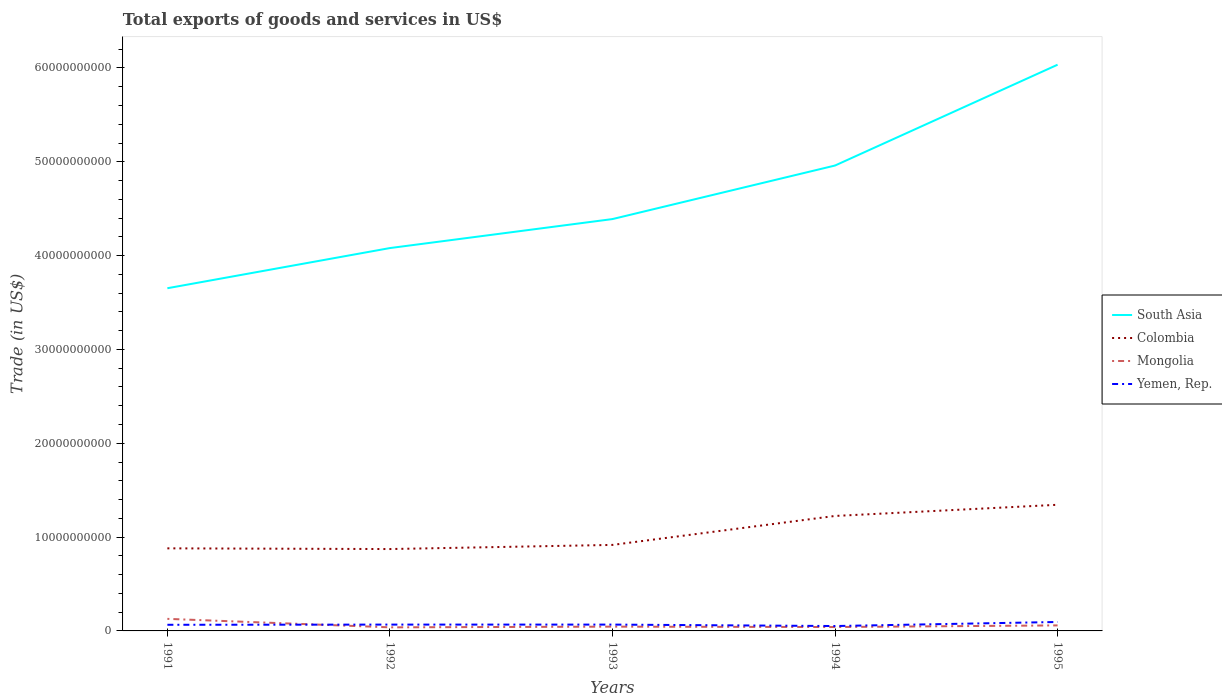Is the number of lines equal to the number of legend labels?
Your response must be concise. Yes. Across all years, what is the maximum total exports of goods and services in Yemen, Rep.?
Your answer should be very brief. 5.21e+08. In which year was the total exports of goods and services in Mongolia maximum?
Offer a terse response. 1992. What is the total total exports of goods and services in Yemen, Rep. in the graph?
Keep it short and to the point. -5.11e+05. What is the difference between the highest and the second highest total exports of goods and services in Yemen, Rep.?
Offer a terse response. 4.32e+08. Is the total exports of goods and services in Yemen, Rep. strictly greater than the total exports of goods and services in Mongolia over the years?
Provide a succinct answer. No. How many lines are there?
Ensure brevity in your answer.  4. How many years are there in the graph?
Offer a terse response. 5. What is the difference between two consecutive major ticks on the Y-axis?
Make the answer very short. 1.00e+1. Are the values on the major ticks of Y-axis written in scientific E-notation?
Keep it short and to the point. No. Does the graph contain any zero values?
Keep it short and to the point. No. Does the graph contain grids?
Offer a terse response. No. Where does the legend appear in the graph?
Keep it short and to the point. Center right. How many legend labels are there?
Provide a succinct answer. 4. How are the legend labels stacked?
Provide a short and direct response. Vertical. What is the title of the graph?
Provide a short and direct response. Total exports of goods and services in US$. What is the label or title of the X-axis?
Your answer should be compact. Years. What is the label or title of the Y-axis?
Give a very brief answer. Trade (in US$). What is the Trade (in US$) in South Asia in 1991?
Provide a short and direct response. 3.65e+1. What is the Trade (in US$) of Colombia in 1991?
Make the answer very short. 8.80e+09. What is the Trade (in US$) in Mongolia in 1991?
Give a very brief answer. 1.29e+09. What is the Trade (in US$) in Yemen, Rep. in 1991?
Your answer should be compact. 6.54e+08. What is the Trade (in US$) of South Asia in 1992?
Offer a very short reply. 4.08e+1. What is the Trade (in US$) of Colombia in 1992?
Give a very brief answer. 8.73e+09. What is the Trade (in US$) of Mongolia in 1992?
Ensure brevity in your answer.  3.81e+08. What is the Trade (in US$) of Yemen, Rep. in 1992?
Make the answer very short. 6.75e+08. What is the Trade (in US$) in South Asia in 1993?
Provide a succinct answer. 4.39e+1. What is the Trade (in US$) of Colombia in 1993?
Keep it short and to the point. 9.17e+09. What is the Trade (in US$) in Mongolia in 1993?
Make the answer very short. 4.56e+08. What is the Trade (in US$) in Yemen, Rep. in 1993?
Your answer should be very brief. 6.75e+08. What is the Trade (in US$) of South Asia in 1994?
Your response must be concise. 4.96e+1. What is the Trade (in US$) of Colombia in 1994?
Give a very brief answer. 1.23e+1. What is the Trade (in US$) in Mongolia in 1994?
Provide a short and direct response. 4.13e+08. What is the Trade (in US$) in Yemen, Rep. in 1994?
Give a very brief answer. 5.21e+08. What is the Trade (in US$) in South Asia in 1995?
Your answer should be very brief. 6.03e+1. What is the Trade (in US$) in Colombia in 1995?
Your answer should be very brief. 1.34e+1. What is the Trade (in US$) of Mongolia in 1995?
Your response must be concise. 5.89e+08. What is the Trade (in US$) of Yemen, Rep. in 1995?
Make the answer very short. 9.53e+08. Across all years, what is the maximum Trade (in US$) in South Asia?
Provide a succinct answer. 6.03e+1. Across all years, what is the maximum Trade (in US$) in Colombia?
Give a very brief answer. 1.34e+1. Across all years, what is the maximum Trade (in US$) in Mongolia?
Offer a very short reply. 1.29e+09. Across all years, what is the maximum Trade (in US$) of Yemen, Rep.?
Give a very brief answer. 9.53e+08. Across all years, what is the minimum Trade (in US$) of South Asia?
Offer a very short reply. 3.65e+1. Across all years, what is the minimum Trade (in US$) of Colombia?
Provide a short and direct response. 8.73e+09. Across all years, what is the minimum Trade (in US$) in Mongolia?
Keep it short and to the point. 3.81e+08. Across all years, what is the minimum Trade (in US$) in Yemen, Rep.?
Your answer should be very brief. 5.21e+08. What is the total Trade (in US$) of South Asia in the graph?
Your answer should be very brief. 2.31e+11. What is the total Trade (in US$) in Colombia in the graph?
Your answer should be very brief. 5.24e+1. What is the total Trade (in US$) of Mongolia in the graph?
Provide a succinct answer. 3.13e+09. What is the total Trade (in US$) in Yemen, Rep. in the graph?
Provide a short and direct response. 3.48e+09. What is the difference between the Trade (in US$) of South Asia in 1991 and that in 1992?
Offer a terse response. -4.28e+09. What is the difference between the Trade (in US$) in Colombia in 1991 and that in 1992?
Your response must be concise. 7.52e+07. What is the difference between the Trade (in US$) of Mongolia in 1991 and that in 1992?
Provide a succinct answer. 9.05e+08. What is the difference between the Trade (in US$) of Yemen, Rep. in 1991 and that in 1992?
Make the answer very short. -2.09e+07. What is the difference between the Trade (in US$) in South Asia in 1991 and that in 1993?
Your answer should be very brief. -7.37e+09. What is the difference between the Trade (in US$) in Colombia in 1991 and that in 1993?
Your answer should be compact. -3.66e+08. What is the difference between the Trade (in US$) of Mongolia in 1991 and that in 1993?
Keep it short and to the point. 8.30e+08. What is the difference between the Trade (in US$) in Yemen, Rep. in 1991 and that in 1993?
Offer a very short reply. -2.14e+07. What is the difference between the Trade (in US$) of South Asia in 1991 and that in 1994?
Provide a short and direct response. -1.31e+1. What is the difference between the Trade (in US$) of Colombia in 1991 and that in 1994?
Provide a succinct answer. -3.45e+09. What is the difference between the Trade (in US$) of Mongolia in 1991 and that in 1994?
Your answer should be compact. 8.73e+08. What is the difference between the Trade (in US$) of Yemen, Rep. in 1991 and that in 1994?
Offer a terse response. 1.32e+08. What is the difference between the Trade (in US$) of South Asia in 1991 and that in 1995?
Offer a terse response. -2.38e+1. What is the difference between the Trade (in US$) in Colombia in 1991 and that in 1995?
Your answer should be very brief. -4.64e+09. What is the difference between the Trade (in US$) of Mongolia in 1991 and that in 1995?
Ensure brevity in your answer.  6.98e+08. What is the difference between the Trade (in US$) in Yemen, Rep. in 1991 and that in 1995?
Make the answer very short. -2.99e+08. What is the difference between the Trade (in US$) in South Asia in 1992 and that in 1993?
Ensure brevity in your answer.  -3.09e+09. What is the difference between the Trade (in US$) of Colombia in 1992 and that in 1993?
Give a very brief answer. -4.41e+08. What is the difference between the Trade (in US$) in Mongolia in 1992 and that in 1993?
Keep it short and to the point. -7.47e+07. What is the difference between the Trade (in US$) of Yemen, Rep. in 1992 and that in 1993?
Provide a succinct answer. -5.11e+05. What is the difference between the Trade (in US$) in South Asia in 1992 and that in 1994?
Your answer should be compact. -8.80e+09. What is the difference between the Trade (in US$) in Colombia in 1992 and that in 1994?
Offer a terse response. -3.53e+09. What is the difference between the Trade (in US$) of Mongolia in 1992 and that in 1994?
Provide a succinct answer. -3.20e+07. What is the difference between the Trade (in US$) of Yemen, Rep. in 1992 and that in 1994?
Provide a succinct answer. 1.53e+08. What is the difference between the Trade (in US$) in South Asia in 1992 and that in 1995?
Give a very brief answer. -1.95e+1. What is the difference between the Trade (in US$) in Colombia in 1992 and that in 1995?
Your answer should be very brief. -4.72e+09. What is the difference between the Trade (in US$) in Mongolia in 1992 and that in 1995?
Your answer should be compact. -2.08e+08. What is the difference between the Trade (in US$) in Yemen, Rep. in 1992 and that in 1995?
Keep it short and to the point. -2.78e+08. What is the difference between the Trade (in US$) of South Asia in 1993 and that in 1994?
Your response must be concise. -5.71e+09. What is the difference between the Trade (in US$) in Colombia in 1993 and that in 1994?
Your answer should be very brief. -3.09e+09. What is the difference between the Trade (in US$) in Mongolia in 1993 and that in 1994?
Make the answer very short. 4.27e+07. What is the difference between the Trade (in US$) in Yemen, Rep. in 1993 and that in 1994?
Offer a very short reply. 1.54e+08. What is the difference between the Trade (in US$) of South Asia in 1993 and that in 1995?
Offer a very short reply. -1.65e+1. What is the difference between the Trade (in US$) in Colombia in 1993 and that in 1995?
Your response must be concise. -4.28e+09. What is the difference between the Trade (in US$) of Mongolia in 1993 and that in 1995?
Offer a very short reply. -1.33e+08. What is the difference between the Trade (in US$) in Yemen, Rep. in 1993 and that in 1995?
Make the answer very short. -2.78e+08. What is the difference between the Trade (in US$) in South Asia in 1994 and that in 1995?
Ensure brevity in your answer.  -1.07e+1. What is the difference between the Trade (in US$) in Colombia in 1994 and that in 1995?
Offer a terse response. -1.19e+09. What is the difference between the Trade (in US$) in Mongolia in 1994 and that in 1995?
Your answer should be compact. -1.76e+08. What is the difference between the Trade (in US$) in Yemen, Rep. in 1994 and that in 1995?
Keep it short and to the point. -4.32e+08. What is the difference between the Trade (in US$) of South Asia in 1991 and the Trade (in US$) of Colombia in 1992?
Your answer should be compact. 2.78e+1. What is the difference between the Trade (in US$) in South Asia in 1991 and the Trade (in US$) in Mongolia in 1992?
Provide a short and direct response. 3.61e+1. What is the difference between the Trade (in US$) of South Asia in 1991 and the Trade (in US$) of Yemen, Rep. in 1992?
Your answer should be very brief. 3.58e+1. What is the difference between the Trade (in US$) in Colombia in 1991 and the Trade (in US$) in Mongolia in 1992?
Give a very brief answer. 8.42e+09. What is the difference between the Trade (in US$) in Colombia in 1991 and the Trade (in US$) in Yemen, Rep. in 1992?
Give a very brief answer. 8.13e+09. What is the difference between the Trade (in US$) of Mongolia in 1991 and the Trade (in US$) of Yemen, Rep. in 1992?
Make the answer very short. 6.12e+08. What is the difference between the Trade (in US$) in South Asia in 1991 and the Trade (in US$) in Colombia in 1993?
Provide a short and direct response. 2.74e+1. What is the difference between the Trade (in US$) in South Asia in 1991 and the Trade (in US$) in Mongolia in 1993?
Your answer should be compact. 3.61e+1. What is the difference between the Trade (in US$) of South Asia in 1991 and the Trade (in US$) of Yemen, Rep. in 1993?
Offer a terse response. 3.58e+1. What is the difference between the Trade (in US$) of Colombia in 1991 and the Trade (in US$) of Mongolia in 1993?
Make the answer very short. 8.35e+09. What is the difference between the Trade (in US$) of Colombia in 1991 and the Trade (in US$) of Yemen, Rep. in 1993?
Make the answer very short. 8.13e+09. What is the difference between the Trade (in US$) of Mongolia in 1991 and the Trade (in US$) of Yemen, Rep. in 1993?
Your answer should be very brief. 6.11e+08. What is the difference between the Trade (in US$) of South Asia in 1991 and the Trade (in US$) of Colombia in 1994?
Provide a succinct answer. 2.43e+1. What is the difference between the Trade (in US$) of South Asia in 1991 and the Trade (in US$) of Mongolia in 1994?
Your answer should be very brief. 3.61e+1. What is the difference between the Trade (in US$) in South Asia in 1991 and the Trade (in US$) in Yemen, Rep. in 1994?
Offer a terse response. 3.60e+1. What is the difference between the Trade (in US$) in Colombia in 1991 and the Trade (in US$) in Mongolia in 1994?
Ensure brevity in your answer.  8.39e+09. What is the difference between the Trade (in US$) of Colombia in 1991 and the Trade (in US$) of Yemen, Rep. in 1994?
Offer a terse response. 8.28e+09. What is the difference between the Trade (in US$) in Mongolia in 1991 and the Trade (in US$) in Yemen, Rep. in 1994?
Provide a succinct answer. 7.65e+08. What is the difference between the Trade (in US$) in South Asia in 1991 and the Trade (in US$) in Colombia in 1995?
Provide a short and direct response. 2.31e+1. What is the difference between the Trade (in US$) of South Asia in 1991 and the Trade (in US$) of Mongolia in 1995?
Give a very brief answer. 3.59e+1. What is the difference between the Trade (in US$) in South Asia in 1991 and the Trade (in US$) in Yemen, Rep. in 1995?
Offer a terse response. 3.56e+1. What is the difference between the Trade (in US$) of Colombia in 1991 and the Trade (in US$) of Mongolia in 1995?
Your answer should be very brief. 8.21e+09. What is the difference between the Trade (in US$) of Colombia in 1991 and the Trade (in US$) of Yemen, Rep. in 1995?
Ensure brevity in your answer.  7.85e+09. What is the difference between the Trade (in US$) of Mongolia in 1991 and the Trade (in US$) of Yemen, Rep. in 1995?
Offer a terse response. 3.33e+08. What is the difference between the Trade (in US$) of South Asia in 1992 and the Trade (in US$) of Colombia in 1993?
Ensure brevity in your answer.  3.16e+1. What is the difference between the Trade (in US$) of South Asia in 1992 and the Trade (in US$) of Mongolia in 1993?
Your answer should be compact. 4.04e+1. What is the difference between the Trade (in US$) in South Asia in 1992 and the Trade (in US$) in Yemen, Rep. in 1993?
Make the answer very short. 4.01e+1. What is the difference between the Trade (in US$) of Colombia in 1992 and the Trade (in US$) of Mongolia in 1993?
Keep it short and to the point. 8.27e+09. What is the difference between the Trade (in US$) of Colombia in 1992 and the Trade (in US$) of Yemen, Rep. in 1993?
Your response must be concise. 8.05e+09. What is the difference between the Trade (in US$) in Mongolia in 1992 and the Trade (in US$) in Yemen, Rep. in 1993?
Make the answer very short. -2.94e+08. What is the difference between the Trade (in US$) in South Asia in 1992 and the Trade (in US$) in Colombia in 1994?
Your answer should be very brief. 2.86e+1. What is the difference between the Trade (in US$) in South Asia in 1992 and the Trade (in US$) in Mongolia in 1994?
Provide a short and direct response. 4.04e+1. What is the difference between the Trade (in US$) of South Asia in 1992 and the Trade (in US$) of Yemen, Rep. in 1994?
Make the answer very short. 4.03e+1. What is the difference between the Trade (in US$) in Colombia in 1992 and the Trade (in US$) in Mongolia in 1994?
Offer a terse response. 8.31e+09. What is the difference between the Trade (in US$) in Colombia in 1992 and the Trade (in US$) in Yemen, Rep. in 1994?
Give a very brief answer. 8.21e+09. What is the difference between the Trade (in US$) of Mongolia in 1992 and the Trade (in US$) of Yemen, Rep. in 1994?
Ensure brevity in your answer.  -1.40e+08. What is the difference between the Trade (in US$) of South Asia in 1992 and the Trade (in US$) of Colombia in 1995?
Make the answer very short. 2.74e+1. What is the difference between the Trade (in US$) in South Asia in 1992 and the Trade (in US$) in Mongolia in 1995?
Ensure brevity in your answer.  4.02e+1. What is the difference between the Trade (in US$) in South Asia in 1992 and the Trade (in US$) in Yemen, Rep. in 1995?
Give a very brief answer. 3.99e+1. What is the difference between the Trade (in US$) in Colombia in 1992 and the Trade (in US$) in Mongolia in 1995?
Make the answer very short. 8.14e+09. What is the difference between the Trade (in US$) in Colombia in 1992 and the Trade (in US$) in Yemen, Rep. in 1995?
Give a very brief answer. 7.77e+09. What is the difference between the Trade (in US$) in Mongolia in 1992 and the Trade (in US$) in Yemen, Rep. in 1995?
Provide a succinct answer. -5.72e+08. What is the difference between the Trade (in US$) of South Asia in 1993 and the Trade (in US$) of Colombia in 1994?
Keep it short and to the point. 3.16e+1. What is the difference between the Trade (in US$) in South Asia in 1993 and the Trade (in US$) in Mongolia in 1994?
Your answer should be very brief. 4.35e+1. What is the difference between the Trade (in US$) in South Asia in 1993 and the Trade (in US$) in Yemen, Rep. in 1994?
Offer a very short reply. 4.34e+1. What is the difference between the Trade (in US$) in Colombia in 1993 and the Trade (in US$) in Mongolia in 1994?
Your answer should be compact. 8.75e+09. What is the difference between the Trade (in US$) in Colombia in 1993 and the Trade (in US$) in Yemen, Rep. in 1994?
Your answer should be very brief. 8.65e+09. What is the difference between the Trade (in US$) in Mongolia in 1993 and the Trade (in US$) in Yemen, Rep. in 1994?
Your answer should be very brief. -6.53e+07. What is the difference between the Trade (in US$) of South Asia in 1993 and the Trade (in US$) of Colombia in 1995?
Your answer should be compact. 3.05e+1. What is the difference between the Trade (in US$) of South Asia in 1993 and the Trade (in US$) of Mongolia in 1995?
Your response must be concise. 4.33e+1. What is the difference between the Trade (in US$) in South Asia in 1993 and the Trade (in US$) in Yemen, Rep. in 1995?
Your answer should be compact. 4.29e+1. What is the difference between the Trade (in US$) in Colombia in 1993 and the Trade (in US$) in Mongolia in 1995?
Keep it short and to the point. 8.58e+09. What is the difference between the Trade (in US$) of Colombia in 1993 and the Trade (in US$) of Yemen, Rep. in 1995?
Keep it short and to the point. 8.21e+09. What is the difference between the Trade (in US$) in Mongolia in 1993 and the Trade (in US$) in Yemen, Rep. in 1995?
Keep it short and to the point. -4.97e+08. What is the difference between the Trade (in US$) in South Asia in 1994 and the Trade (in US$) in Colombia in 1995?
Your answer should be very brief. 3.62e+1. What is the difference between the Trade (in US$) of South Asia in 1994 and the Trade (in US$) of Mongolia in 1995?
Make the answer very short. 4.90e+1. What is the difference between the Trade (in US$) of South Asia in 1994 and the Trade (in US$) of Yemen, Rep. in 1995?
Your response must be concise. 4.87e+1. What is the difference between the Trade (in US$) in Colombia in 1994 and the Trade (in US$) in Mongolia in 1995?
Offer a very short reply. 1.17e+1. What is the difference between the Trade (in US$) of Colombia in 1994 and the Trade (in US$) of Yemen, Rep. in 1995?
Make the answer very short. 1.13e+1. What is the difference between the Trade (in US$) of Mongolia in 1994 and the Trade (in US$) of Yemen, Rep. in 1995?
Make the answer very short. -5.40e+08. What is the average Trade (in US$) in South Asia per year?
Provide a succinct answer. 4.62e+1. What is the average Trade (in US$) in Colombia per year?
Offer a very short reply. 1.05e+1. What is the average Trade (in US$) of Mongolia per year?
Offer a terse response. 6.25e+08. What is the average Trade (in US$) of Yemen, Rep. per year?
Keep it short and to the point. 6.96e+08. In the year 1991, what is the difference between the Trade (in US$) of South Asia and Trade (in US$) of Colombia?
Your response must be concise. 2.77e+1. In the year 1991, what is the difference between the Trade (in US$) of South Asia and Trade (in US$) of Mongolia?
Provide a succinct answer. 3.52e+1. In the year 1991, what is the difference between the Trade (in US$) of South Asia and Trade (in US$) of Yemen, Rep.?
Give a very brief answer. 3.59e+1. In the year 1991, what is the difference between the Trade (in US$) in Colombia and Trade (in US$) in Mongolia?
Ensure brevity in your answer.  7.52e+09. In the year 1991, what is the difference between the Trade (in US$) in Colombia and Trade (in US$) in Yemen, Rep.?
Offer a terse response. 8.15e+09. In the year 1991, what is the difference between the Trade (in US$) in Mongolia and Trade (in US$) in Yemen, Rep.?
Provide a short and direct response. 6.33e+08. In the year 1992, what is the difference between the Trade (in US$) of South Asia and Trade (in US$) of Colombia?
Your answer should be very brief. 3.21e+1. In the year 1992, what is the difference between the Trade (in US$) in South Asia and Trade (in US$) in Mongolia?
Offer a very short reply. 4.04e+1. In the year 1992, what is the difference between the Trade (in US$) of South Asia and Trade (in US$) of Yemen, Rep.?
Provide a short and direct response. 4.01e+1. In the year 1992, what is the difference between the Trade (in US$) of Colombia and Trade (in US$) of Mongolia?
Keep it short and to the point. 8.35e+09. In the year 1992, what is the difference between the Trade (in US$) of Colombia and Trade (in US$) of Yemen, Rep.?
Give a very brief answer. 8.05e+09. In the year 1992, what is the difference between the Trade (in US$) in Mongolia and Trade (in US$) in Yemen, Rep.?
Keep it short and to the point. -2.93e+08. In the year 1993, what is the difference between the Trade (in US$) in South Asia and Trade (in US$) in Colombia?
Offer a very short reply. 3.47e+1. In the year 1993, what is the difference between the Trade (in US$) of South Asia and Trade (in US$) of Mongolia?
Your answer should be very brief. 4.34e+1. In the year 1993, what is the difference between the Trade (in US$) in South Asia and Trade (in US$) in Yemen, Rep.?
Offer a very short reply. 4.32e+1. In the year 1993, what is the difference between the Trade (in US$) in Colombia and Trade (in US$) in Mongolia?
Offer a very short reply. 8.71e+09. In the year 1993, what is the difference between the Trade (in US$) in Colombia and Trade (in US$) in Yemen, Rep.?
Give a very brief answer. 8.49e+09. In the year 1993, what is the difference between the Trade (in US$) in Mongolia and Trade (in US$) in Yemen, Rep.?
Your answer should be compact. -2.19e+08. In the year 1994, what is the difference between the Trade (in US$) in South Asia and Trade (in US$) in Colombia?
Provide a succinct answer. 3.73e+1. In the year 1994, what is the difference between the Trade (in US$) in South Asia and Trade (in US$) in Mongolia?
Ensure brevity in your answer.  4.92e+1. In the year 1994, what is the difference between the Trade (in US$) of South Asia and Trade (in US$) of Yemen, Rep.?
Your answer should be very brief. 4.91e+1. In the year 1994, what is the difference between the Trade (in US$) in Colombia and Trade (in US$) in Mongolia?
Make the answer very short. 1.18e+1. In the year 1994, what is the difference between the Trade (in US$) of Colombia and Trade (in US$) of Yemen, Rep.?
Ensure brevity in your answer.  1.17e+1. In the year 1994, what is the difference between the Trade (in US$) of Mongolia and Trade (in US$) of Yemen, Rep.?
Offer a very short reply. -1.08e+08. In the year 1995, what is the difference between the Trade (in US$) in South Asia and Trade (in US$) in Colombia?
Offer a very short reply. 4.69e+1. In the year 1995, what is the difference between the Trade (in US$) in South Asia and Trade (in US$) in Mongolia?
Give a very brief answer. 5.98e+1. In the year 1995, what is the difference between the Trade (in US$) of South Asia and Trade (in US$) of Yemen, Rep.?
Provide a succinct answer. 5.94e+1. In the year 1995, what is the difference between the Trade (in US$) of Colombia and Trade (in US$) of Mongolia?
Your response must be concise. 1.29e+1. In the year 1995, what is the difference between the Trade (in US$) of Colombia and Trade (in US$) of Yemen, Rep.?
Your answer should be very brief. 1.25e+1. In the year 1995, what is the difference between the Trade (in US$) in Mongolia and Trade (in US$) in Yemen, Rep.?
Offer a terse response. -3.64e+08. What is the ratio of the Trade (in US$) of South Asia in 1991 to that in 1992?
Ensure brevity in your answer.  0.9. What is the ratio of the Trade (in US$) of Colombia in 1991 to that in 1992?
Your answer should be compact. 1.01. What is the ratio of the Trade (in US$) of Mongolia in 1991 to that in 1992?
Provide a succinct answer. 3.37. What is the ratio of the Trade (in US$) of South Asia in 1991 to that in 1993?
Offer a terse response. 0.83. What is the ratio of the Trade (in US$) of Colombia in 1991 to that in 1993?
Your response must be concise. 0.96. What is the ratio of the Trade (in US$) in Mongolia in 1991 to that in 1993?
Offer a terse response. 2.82. What is the ratio of the Trade (in US$) of Yemen, Rep. in 1991 to that in 1993?
Make the answer very short. 0.97. What is the ratio of the Trade (in US$) in South Asia in 1991 to that in 1994?
Give a very brief answer. 0.74. What is the ratio of the Trade (in US$) in Colombia in 1991 to that in 1994?
Make the answer very short. 0.72. What is the ratio of the Trade (in US$) of Mongolia in 1991 to that in 1994?
Your answer should be very brief. 3.11. What is the ratio of the Trade (in US$) in Yemen, Rep. in 1991 to that in 1994?
Give a very brief answer. 1.25. What is the ratio of the Trade (in US$) of South Asia in 1991 to that in 1995?
Provide a short and direct response. 0.61. What is the ratio of the Trade (in US$) in Colombia in 1991 to that in 1995?
Your answer should be compact. 0.65. What is the ratio of the Trade (in US$) of Mongolia in 1991 to that in 1995?
Offer a terse response. 2.18. What is the ratio of the Trade (in US$) of Yemen, Rep. in 1991 to that in 1995?
Make the answer very short. 0.69. What is the ratio of the Trade (in US$) of South Asia in 1992 to that in 1993?
Keep it short and to the point. 0.93. What is the ratio of the Trade (in US$) in Colombia in 1992 to that in 1993?
Give a very brief answer. 0.95. What is the ratio of the Trade (in US$) in Mongolia in 1992 to that in 1993?
Ensure brevity in your answer.  0.84. What is the ratio of the Trade (in US$) in South Asia in 1992 to that in 1994?
Your answer should be compact. 0.82. What is the ratio of the Trade (in US$) in Colombia in 1992 to that in 1994?
Provide a succinct answer. 0.71. What is the ratio of the Trade (in US$) in Mongolia in 1992 to that in 1994?
Your response must be concise. 0.92. What is the ratio of the Trade (in US$) of Yemen, Rep. in 1992 to that in 1994?
Offer a very short reply. 1.29. What is the ratio of the Trade (in US$) in South Asia in 1992 to that in 1995?
Keep it short and to the point. 0.68. What is the ratio of the Trade (in US$) of Colombia in 1992 to that in 1995?
Offer a very short reply. 0.65. What is the ratio of the Trade (in US$) of Mongolia in 1992 to that in 1995?
Provide a short and direct response. 0.65. What is the ratio of the Trade (in US$) in Yemen, Rep. in 1992 to that in 1995?
Give a very brief answer. 0.71. What is the ratio of the Trade (in US$) of South Asia in 1993 to that in 1994?
Give a very brief answer. 0.89. What is the ratio of the Trade (in US$) of Colombia in 1993 to that in 1994?
Provide a succinct answer. 0.75. What is the ratio of the Trade (in US$) in Mongolia in 1993 to that in 1994?
Your response must be concise. 1.1. What is the ratio of the Trade (in US$) in Yemen, Rep. in 1993 to that in 1994?
Your answer should be compact. 1.3. What is the ratio of the Trade (in US$) of South Asia in 1993 to that in 1995?
Offer a terse response. 0.73. What is the ratio of the Trade (in US$) of Colombia in 1993 to that in 1995?
Provide a succinct answer. 0.68. What is the ratio of the Trade (in US$) in Mongolia in 1993 to that in 1995?
Your response must be concise. 0.77. What is the ratio of the Trade (in US$) of Yemen, Rep. in 1993 to that in 1995?
Ensure brevity in your answer.  0.71. What is the ratio of the Trade (in US$) in South Asia in 1994 to that in 1995?
Make the answer very short. 0.82. What is the ratio of the Trade (in US$) in Colombia in 1994 to that in 1995?
Ensure brevity in your answer.  0.91. What is the ratio of the Trade (in US$) in Mongolia in 1994 to that in 1995?
Your response must be concise. 0.7. What is the ratio of the Trade (in US$) of Yemen, Rep. in 1994 to that in 1995?
Offer a very short reply. 0.55. What is the difference between the highest and the second highest Trade (in US$) in South Asia?
Provide a succinct answer. 1.07e+1. What is the difference between the highest and the second highest Trade (in US$) of Colombia?
Your answer should be compact. 1.19e+09. What is the difference between the highest and the second highest Trade (in US$) in Mongolia?
Provide a succinct answer. 6.98e+08. What is the difference between the highest and the second highest Trade (in US$) of Yemen, Rep.?
Provide a short and direct response. 2.78e+08. What is the difference between the highest and the lowest Trade (in US$) of South Asia?
Provide a short and direct response. 2.38e+1. What is the difference between the highest and the lowest Trade (in US$) of Colombia?
Your answer should be compact. 4.72e+09. What is the difference between the highest and the lowest Trade (in US$) in Mongolia?
Ensure brevity in your answer.  9.05e+08. What is the difference between the highest and the lowest Trade (in US$) in Yemen, Rep.?
Make the answer very short. 4.32e+08. 